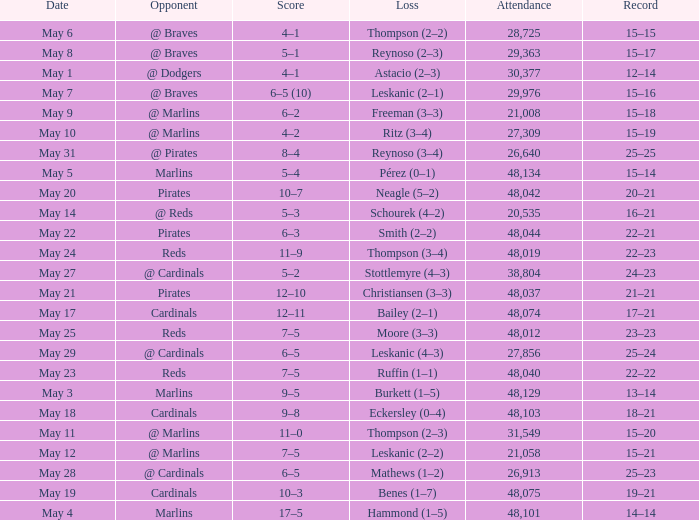Who did the Rockies play at the game that had a score of 6–5 (10)? @ Braves. 